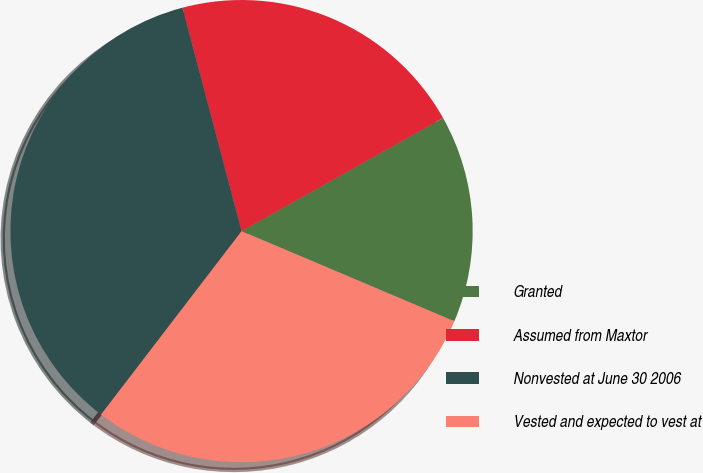<chart> <loc_0><loc_0><loc_500><loc_500><pie_chart><fcel>Granted<fcel>Assumed from Maxtor<fcel>Nonvested at June 30 2006<fcel>Vested and expected to vest at<nl><fcel>14.52%<fcel>20.97%<fcel>35.48%<fcel>29.03%<nl></chart> 